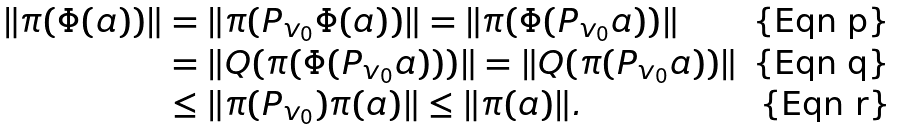<formula> <loc_0><loc_0><loc_500><loc_500>\| \pi ( \Phi ( a ) ) \| & = \| \pi ( P _ { v _ { 0 } } \Phi ( a ) ) \| = \| \pi ( \Phi ( P _ { v _ { 0 } } a ) ) \| \\ & = \| Q ( \pi ( \Phi ( P _ { v _ { 0 } } a ) ) ) \| = \| Q ( \pi ( P _ { v _ { 0 } } a ) ) \| \\ & \leq \| \pi ( P _ { v _ { 0 } } ) \pi ( a ) \| \leq \| \pi ( a ) \| .</formula> 